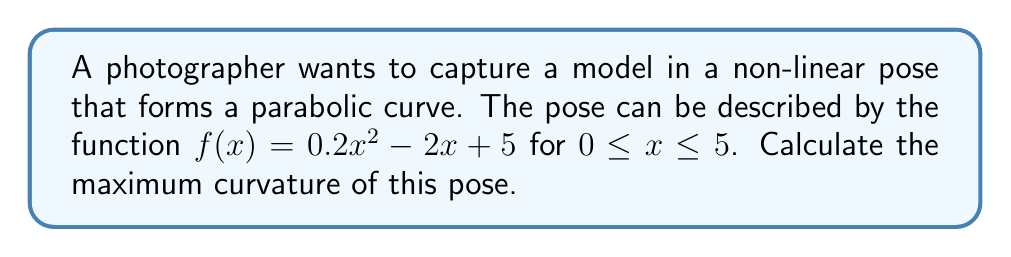Can you answer this question? To find the maximum curvature of the non-linear pose, we'll follow these steps:

1) The curvature $\kappa$ of a function $f(x)$ is given by:

   $$\kappa = \frac{|f''(x)|}{(1 + (f'(x))^2)^{3/2}}$$

2) First, let's find $f'(x)$ and $f''(x)$:
   
   $f'(x) = 0.4x - 2$
   $f''(x) = 0.4$

3) Substitute these into the curvature formula:

   $$\kappa = \frac{|0.4|}{(1 + (0.4x - 2)^2)^{3/2}}$$

4) To find the maximum curvature, we need to find where the denominator is at its minimum (since the numerator is constant).

5) The denominator will be at its minimum when $(0.4x - 2)^2$ is at its minimum, which occurs when $0.4x - 2 = 0$.

6) Solve for x:
   
   $0.4x = 2$
   $x = 5$

7) Calculate the maximum curvature by plugging $x = 5$ into the curvature formula:

   $$\kappa_{max} = \frac{0.4}{(1 + (0.4(5) - 2)^2)^{3/2}} = \frac{0.4}{1^{3/2}} = 0.4$$
Answer: $0.4$ 